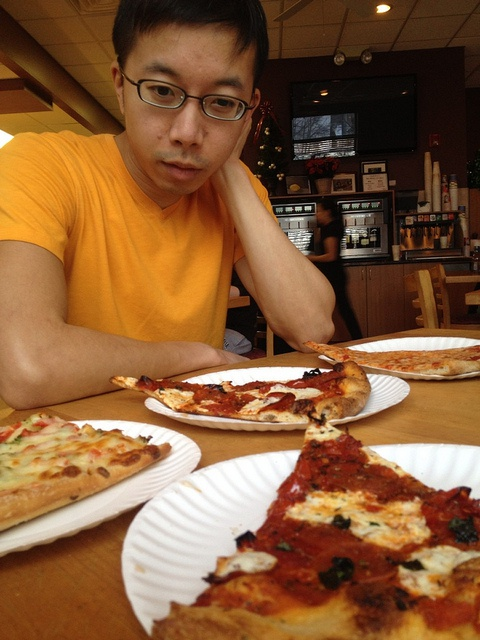Describe the objects in this image and their specific colors. I can see people in maroon, brown, orange, and gray tones, pizza in maroon, brown, and tan tones, dining table in maroon, brown, and gray tones, pizza in black, tan, red, and orange tones, and tv in black, gray, and darkgray tones in this image. 